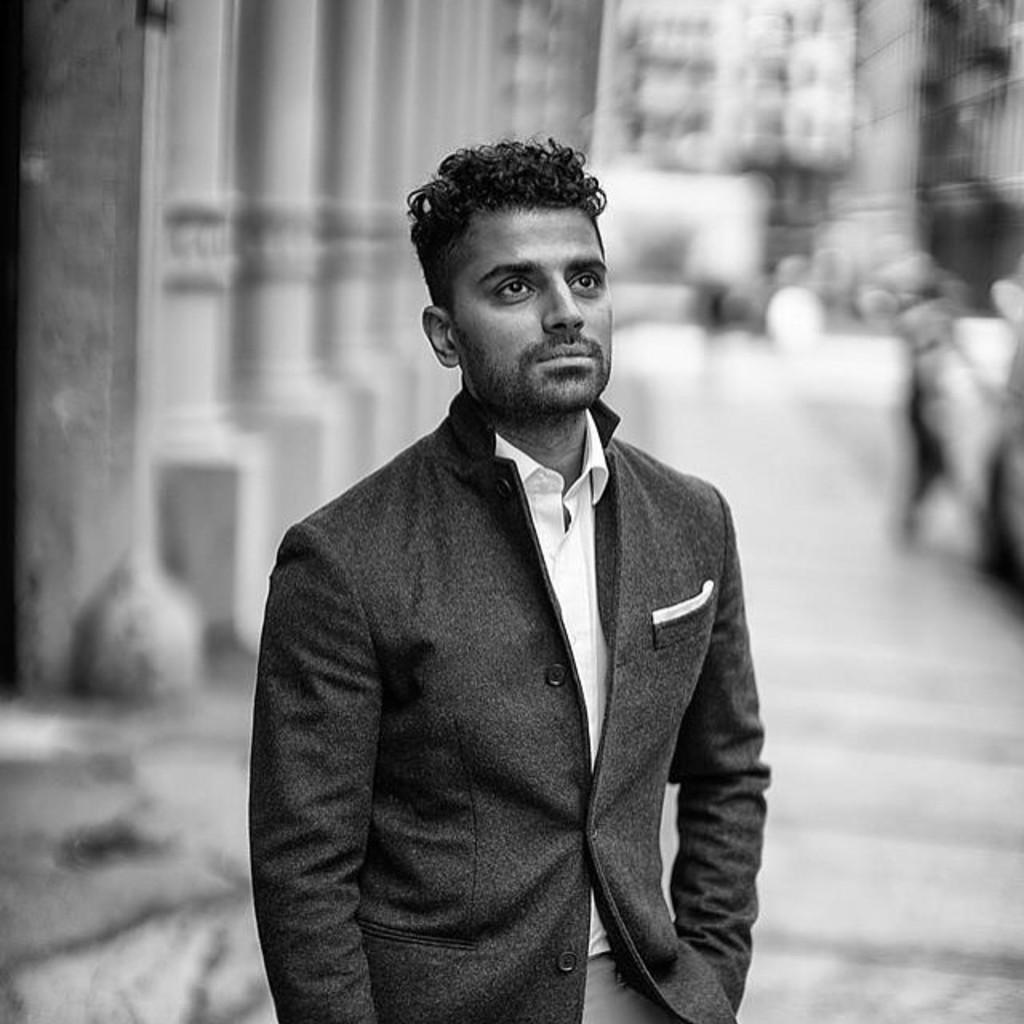What is the main subject of the image? There is a person standing in the image. Can you describe the background of the image? The background of the image is blurred. What type of record can be seen on the person's head in the image? There is no record present in the image; the person is not wearing or holding any record. 